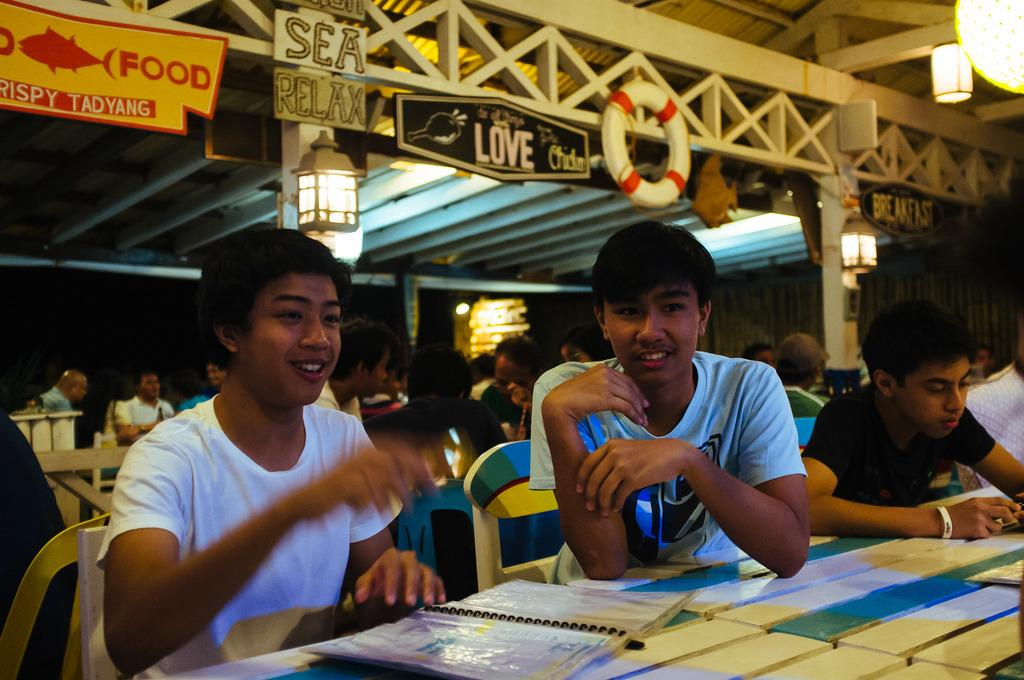What are the people in the image doing? The persons in the image are sitting on chairs in front of a table. What is on the table in the image? There is a spiral book on the table. What can be seen in the background of the image? There is a tube, lanterns, and boards visible in the background. What does the father in the image use to protect himself from fear? There is no mention of a father or fear in the image, so it is not possible to answer that question. 